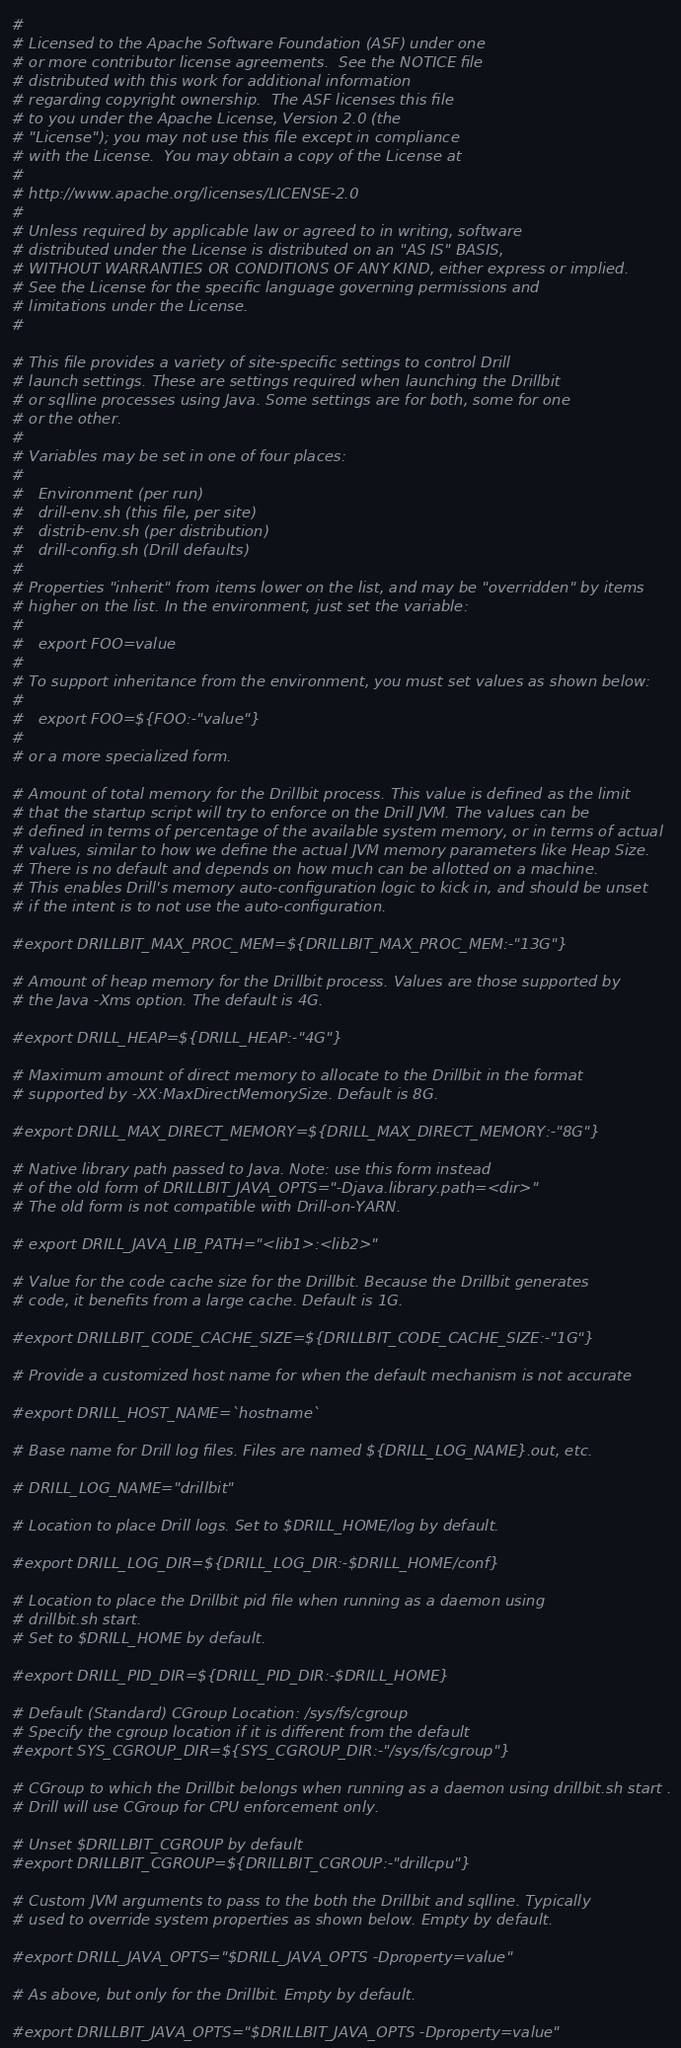Convert code to text. <code><loc_0><loc_0><loc_500><loc_500><_Bash_>#
# Licensed to the Apache Software Foundation (ASF) under one
# or more contributor license agreements.  See the NOTICE file
# distributed with this work for additional information
# regarding copyright ownership.  The ASF licenses this file
# to you under the Apache License, Version 2.0 (the
# "License"); you may not use this file except in compliance
# with the License.  You may obtain a copy of the License at
#
# http://www.apache.org/licenses/LICENSE-2.0
#
# Unless required by applicable law or agreed to in writing, software
# distributed under the License is distributed on an "AS IS" BASIS,
# WITHOUT WARRANTIES OR CONDITIONS OF ANY KIND, either express or implied.
# See the License for the specific language governing permissions and
# limitations under the License.
#

# This file provides a variety of site-specific settings to control Drill
# launch settings. These are settings required when launching the Drillbit
# or sqlline processes using Java. Some settings are for both, some for one
# or the other.
#
# Variables may be set in one of four places:
#
#   Environment (per run)
#   drill-env.sh (this file, per site)
#   distrib-env.sh (per distribution)
#   drill-config.sh (Drill defaults)
#
# Properties "inherit" from items lower on the list, and may be "overridden" by items
# higher on the list. In the environment, just set the variable:
#
#   export FOO=value
#
# To support inheritance from the environment, you must set values as shown below:
#
#   export FOO=${FOO:-"value"}
#
# or a more specialized form.

# Amount of total memory for the Drillbit process. This value is defined as the limit
# that the startup script will try to enforce on the Drill JVM. The values can be
# defined in terms of percentage of the available system memory, or in terms of actual
# values, similar to how we define the actual JVM memory parameters like Heap Size.
# There is no default and depends on how much can be allotted on a machine.
# This enables Drill's memory auto-configuration logic to kick in, and should be unset
# if the intent is to not use the auto-configuration.

#export DRILLBIT_MAX_PROC_MEM=${DRILLBIT_MAX_PROC_MEM:-"13G"}

# Amount of heap memory for the Drillbit process. Values are those supported by
# the Java -Xms option. The default is 4G.

#export DRILL_HEAP=${DRILL_HEAP:-"4G"}

# Maximum amount of direct memory to allocate to the Drillbit in the format
# supported by -XX:MaxDirectMemorySize. Default is 8G.

#export DRILL_MAX_DIRECT_MEMORY=${DRILL_MAX_DIRECT_MEMORY:-"8G"}

# Native library path passed to Java. Note: use this form instead
# of the old form of DRILLBIT_JAVA_OPTS="-Djava.library.path=<dir>"
# The old form is not compatible with Drill-on-YARN.

# export DRILL_JAVA_LIB_PATH="<lib1>:<lib2>"

# Value for the code cache size for the Drillbit. Because the Drillbit generates
# code, it benefits from a large cache. Default is 1G.

#export DRILLBIT_CODE_CACHE_SIZE=${DRILLBIT_CODE_CACHE_SIZE:-"1G"}

# Provide a customized host name for when the default mechanism is not accurate

#export DRILL_HOST_NAME=`hostname`

# Base name for Drill log files. Files are named ${DRILL_LOG_NAME}.out, etc.

# DRILL_LOG_NAME="drillbit"

# Location to place Drill logs. Set to $DRILL_HOME/log by default.

#export DRILL_LOG_DIR=${DRILL_LOG_DIR:-$DRILL_HOME/conf}

# Location to place the Drillbit pid file when running as a daemon using
# drillbit.sh start.
# Set to $DRILL_HOME by default.

#export DRILL_PID_DIR=${DRILL_PID_DIR:-$DRILL_HOME}

# Default (Standard) CGroup Location: /sys/fs/cgroup
# Specify the cgroup location if it is different from the default
#export SYS_CGROUP_DIR=${SYS_CGROUP_DIR:-"/sys/fs/cgroup"}

# CGroup to which the Drillbit belongs when running as a daemon using drillbit.sh start .
# Drill will use CGroup for CPU enforcement only.

# Unset $DRILLBIT_CGROUP by default
#export DRILLBIT_CGROUP=${DRILLBIT_CGROUP:-"drillcpu"}

# Custom JVM arguments to pass to the both the Drillbit and sqlline. Typically
# used to override system properties as shown below. Empty by default.

#export DRILL_JAVA_OPTS="$DRILL_JAVA_OPTS -Dproperty=value"

# As above, but only for the Drillbit. Empty by default.

#export DRILLBIT_JAVA_OPTS="$DRILLBIT_JAVA_OPTS -Dproperty=value"
</code> 